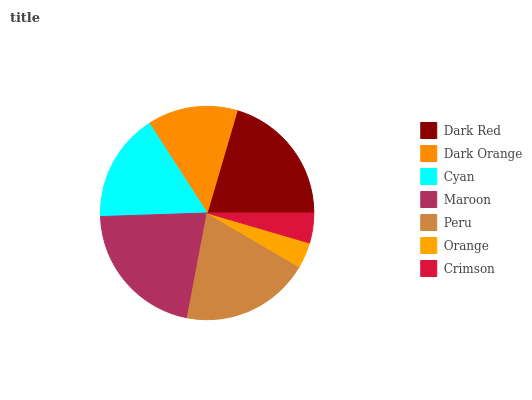Is Orange the minimum?
Answer yes or no. Yes. Is Maroon the maximum?
Answer yes or no. Yes. Is Dark Orange the minimum?
Answer yes or no. No. Is Dark Orange the maximum?
Answer yes or no. No. Is Dark Red greater than Dark Orange?
Answer yes or no. Yes. Is Dark Orange less than Dark Red?
Answer yes or no. Yes. Is Dark Orange greater than Dark Red?
Answer yes or no. No. Is Dark Red less than Dark Orange?
Answer yes or no. No. Is Cyan the high median?
Answer yes or no. Yes. Is Cyan the low median?
Answer yes or no. Yes. Is Dark Red the high median?
Answer yes or no. No. Is Peru the low median?
Answer yes or no. No. 